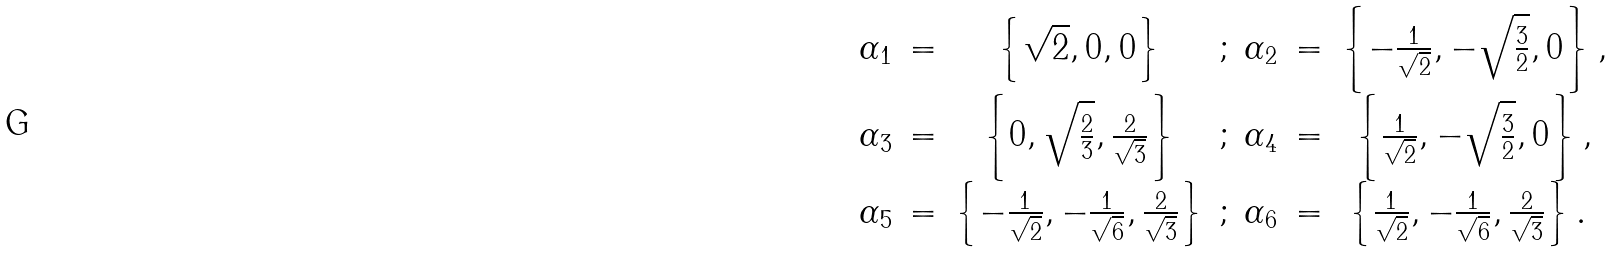Convert formula to latex. <formula><loc_0><loc_0><loc_500><loc_500>\begin{array} { c c c c c c c } \alpha _ { 1 } & = & \left \{ { \sqrt { 2 } } , 0 , 0 \right \} & ; & \alpha _ { 2 } & = & \left \{ - \frac { 1 } { { \sqrt { 2 } } } , - { \sqrt { \frac { 3 } { 2 } } } , 0 \right \} , \\ \alpha _ { 3 } & = & \left \{ 0 , { \sqrt { \frac { 2 } { 3 } } } , \frac { 2 } { { \sqrt { 3 } } } \right \} & ; & \alpha _ { 4 } & = & \left \{ \frac { 1 } { { \sqrt { 2 } } } , - { \sqrt { \frac { 3 } { 2 } } } , 0 \right \} , \\ \alpha _ { 5 } & = & \left \{ - \frac { 1 } { { \sqrt { 2 } } } , - \frac { 1 } { { \sqrt { 6 } } } , \frac { 2 } { { \sqrt { 3 } } } \right \} & ; & \alpha _ { 6 } & = & \left \{ \frac { 1 } { { \sqrt { 2 } } } , - \frac { 1 } { { \sqrt { 6 } } } , \frac { 2 } { { \sqrt { 3 } } } \right \} . \ \end{array}</formula> 